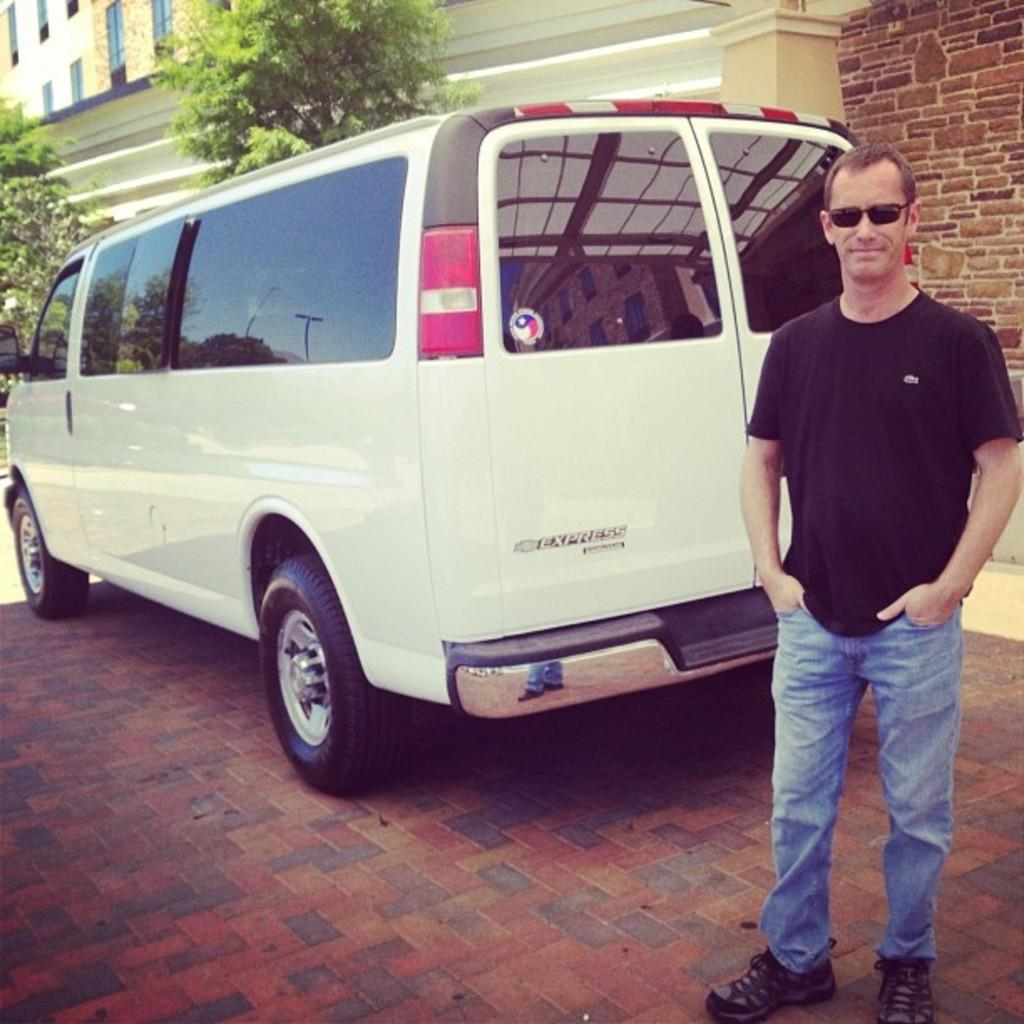What is the main subject of the image? There is a man standing in the image. Can you describe the man's appearance? The man is wearing glasses. What can be seen on the surface in the image? There is a car on the surface in the image. What is visible in the background of the image? There is visible in the background of the image. How many elements can be seen in the background of the image? There are three elements visible in the background: a wall, trees, and windows. How many sheep are visible in the image? There are no sheep present in the image. What type of vein is visible on the man's forehead in the image? There is no visible vein on the man's forehead in the image. 